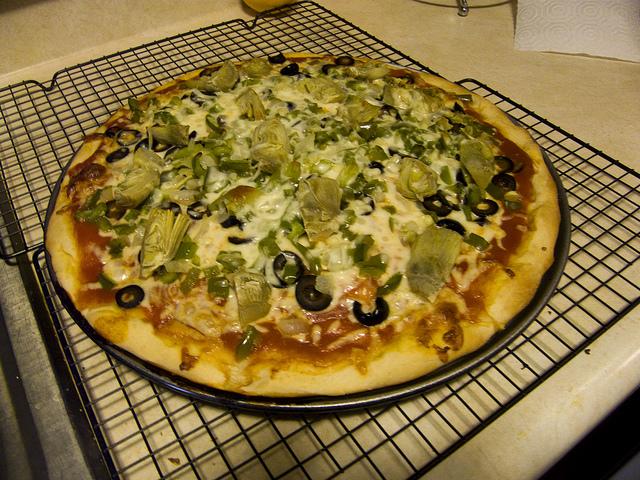Is there pepperoni on the pizza?
Give a very brief answer. No. Is there meat on the pizza?
Give a very brief answer. No. Is this pizza freshly made and ready to bake?
Write a very short answer. Yes. Where was the pizza baked?
Be succinct. Oven. How large is the pizza?
Give a very brief answer. Large. What is the gooey stuff on the pizza?
Short answer required. Cheese. What fruit is on the top pizza?
Write a very short answer. None. What are the black things on the pizza?
Keep it brief. Olives. Are there artichoke hearts on the pizza?
Be succinct. Yes. 